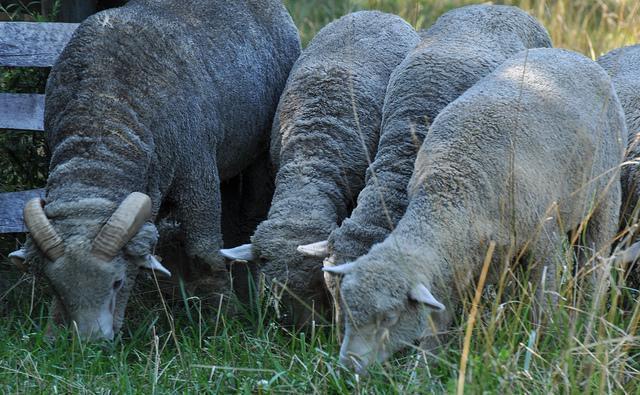A fleece is a kind of hair getting from which mammal?
Pick the correct solution from the four options below to address the question.
Options: Bear, goat, sheep, deer. Sheep. 